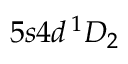Convert formula to latex. <formula><loc_0><loc_0><loc_500><loc_500>5 s 4 d \, ^ { 1 } D _ { 2 }</formula> 